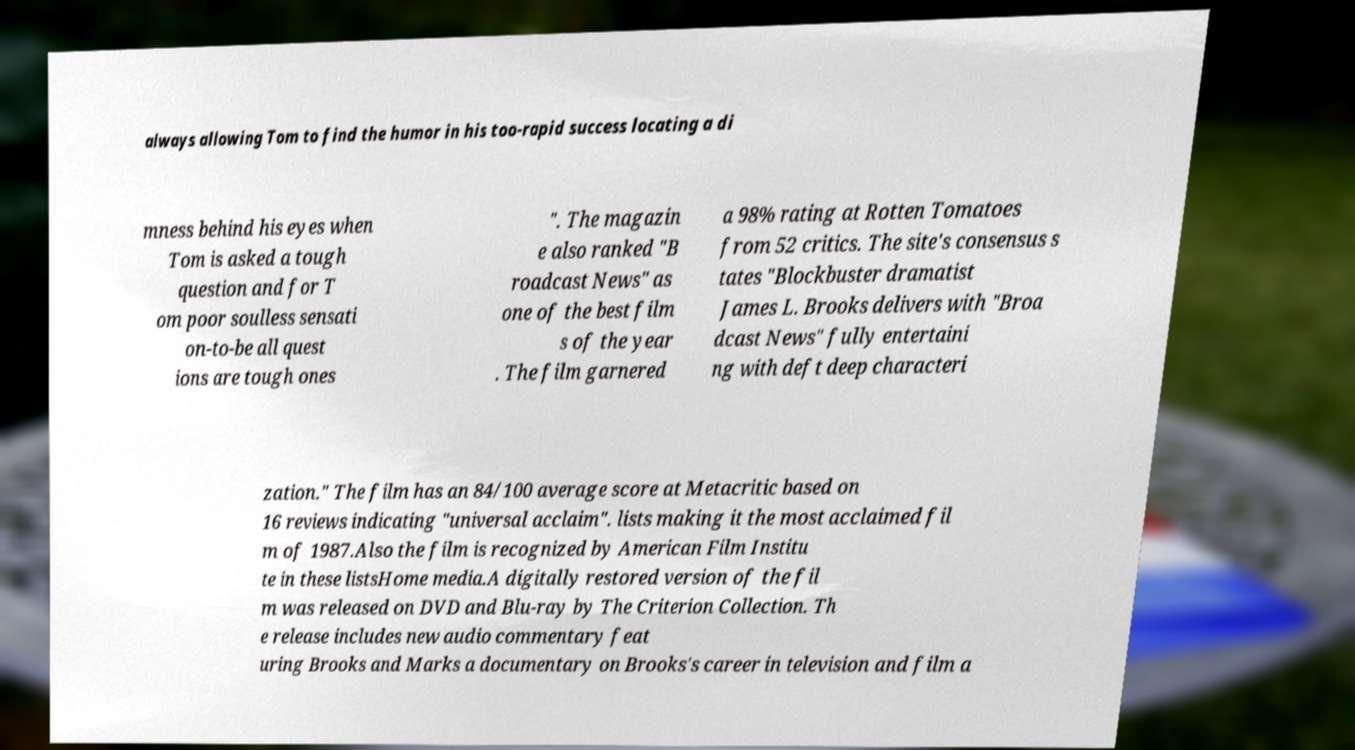Please identify and transcribe the text found in this image. always allowing Tom to find the humor in his too-rapid success locating a di mness behind his eyes when Tom is asked a tough question and for T om poor soulless sensati on-to-be all quest ions are tough ones ". The magazin e also ranked "B roadcast News" as one of the best film s of the year . The film garnered a 98% rating at Rotten Tomatoes from 52 critics. The site's consensus s tates "Blockbuster dramatist James L. Brooks delivers with "Broa dcast News" fully entertaini ng with deft deep characteri zation." The film has an 84/100 average score at Metacritic based on 16 reviews indicating "universal acclaim". lists making it the most acclaimed fil m of 1987.Also the film is recognized by American Film Institu te in these listsHome media.A digitally restored version of the fil m was released on DVD and Blu-ray by The Criterion Collection. Th e release includes new audio commentary feat uring Brooks and Marks a documentary on Brooks's career in television and film a 